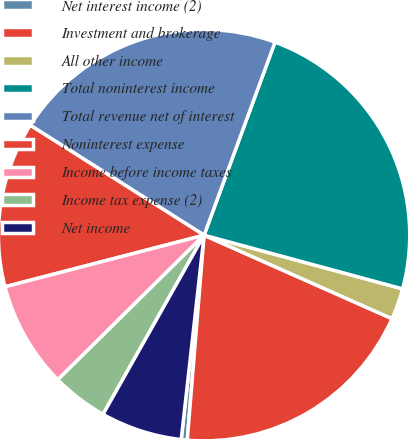Convert chart to OTSL. <chart><loc_0><loc_0><loc_500><loc_500><pie_chart><fcel>Net interest income (2)<fcel>Investment and brokerage<fcel>All other income<fcel>Total noninterest income<fcel>Total revenue net of interest<fcel>Noninterest expense<fcel>Income before income taxes<fcel>Income tax expense (2)<fcel>Net income<nl><fcel>0.47%<fcel>19.65%<fcel>2.45%<fcel>23.6%<fcel>21.63%<fcel>13.01%<fcel>8.37%<fcel>4.42%<fcel>6.4%<nl></chart> 